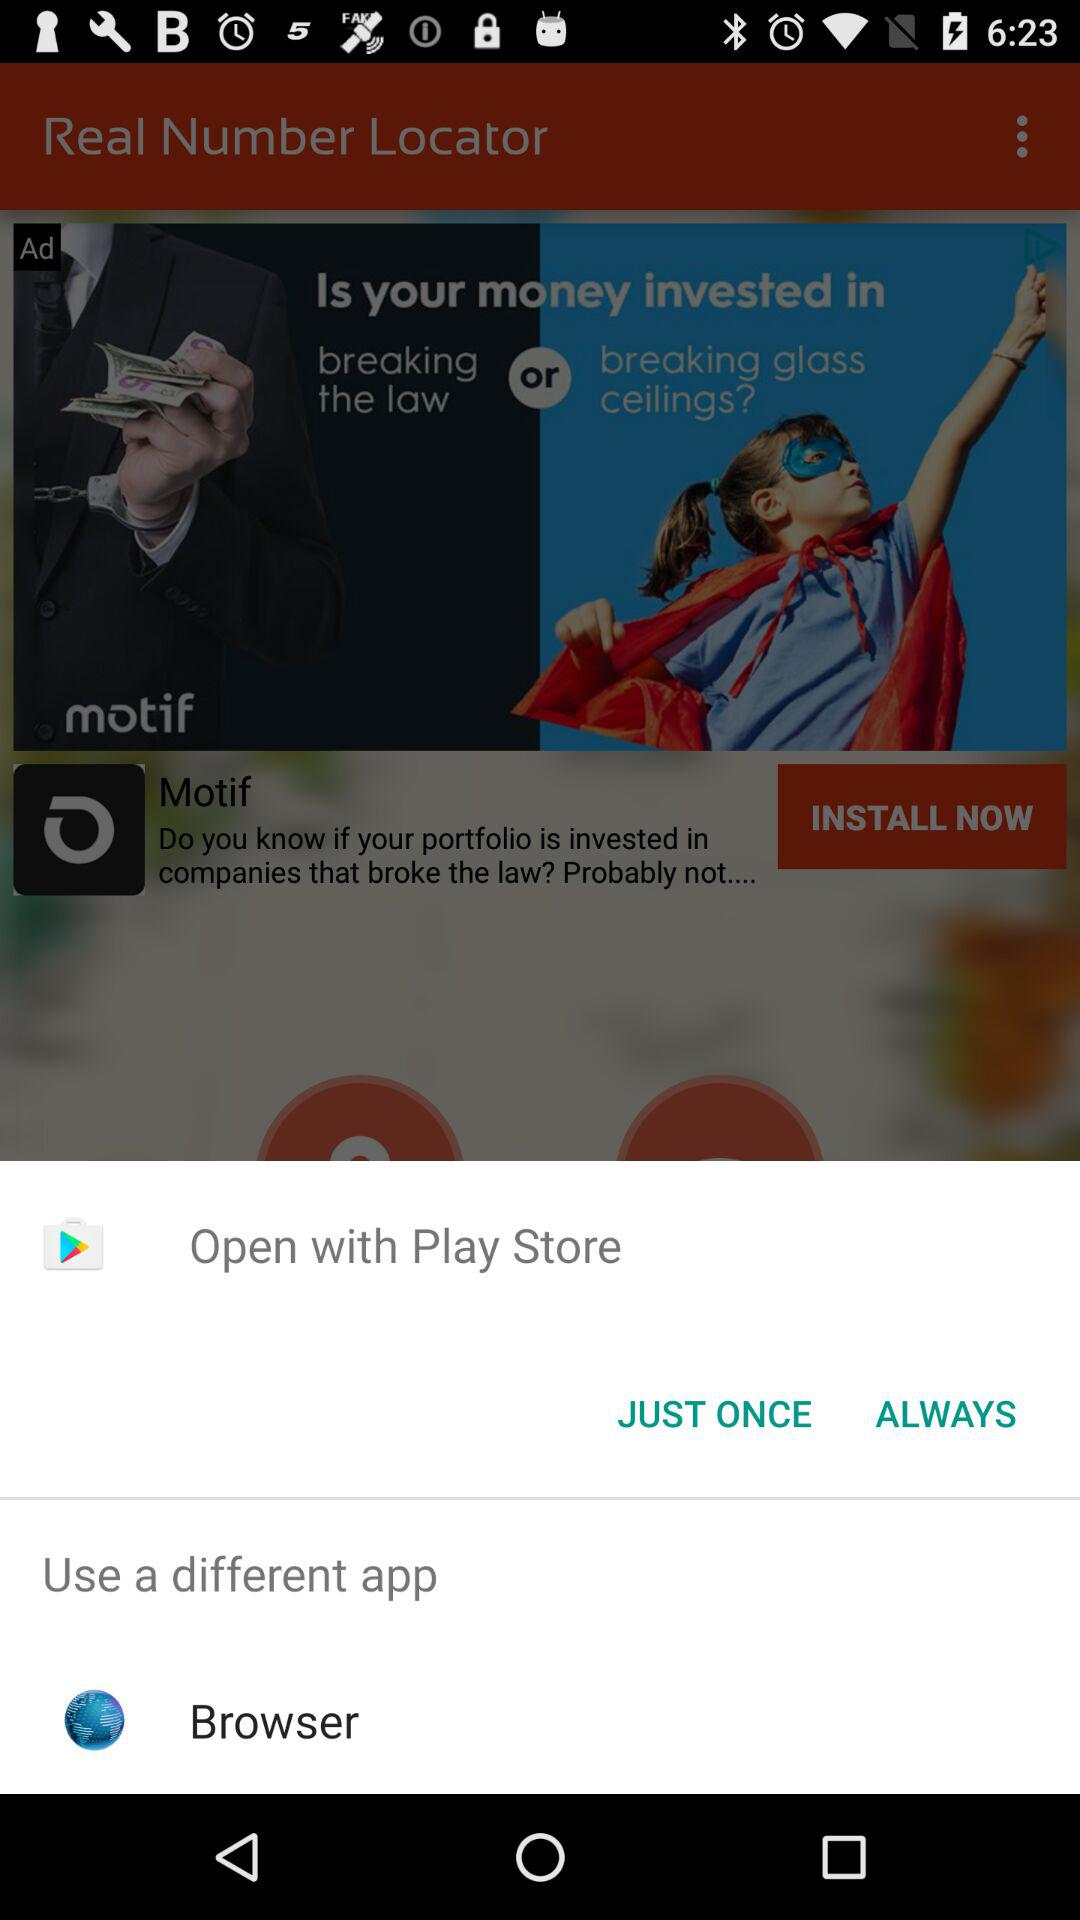What are the different options through which we can open? The different options to open are "Play Store" and "Browser". 